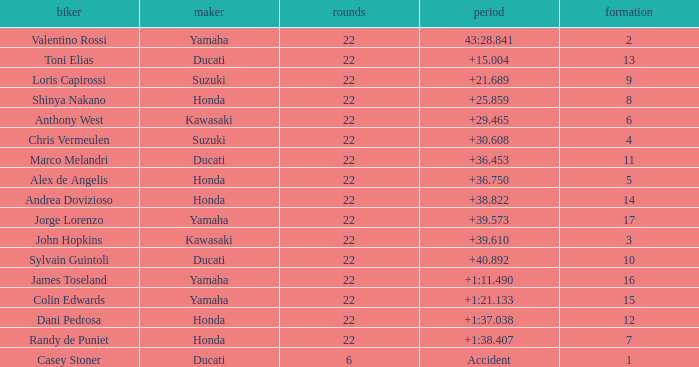What grid is Ducati with fewer than 22 laps? 1.0. 